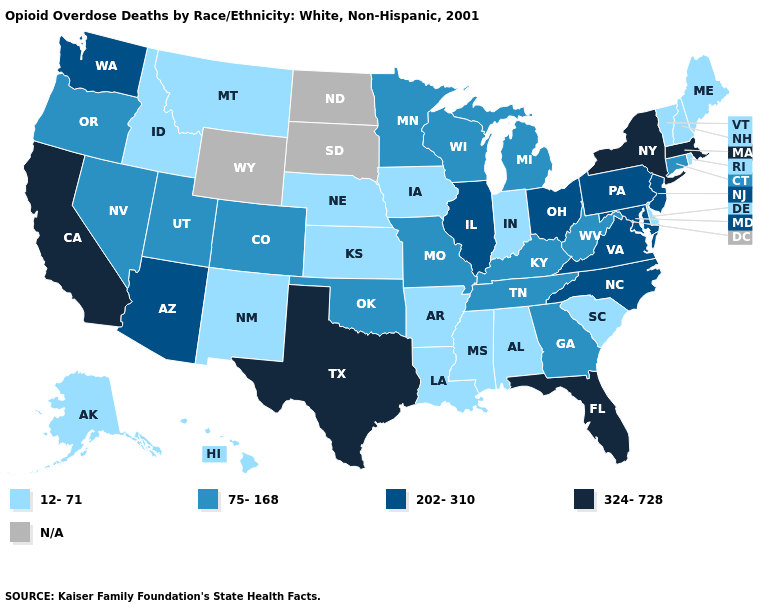What is the highest value in states that border Wisconsin?
Give a very brief answer. 202-310. Which states have the highest value in the USA?
Short answer required. California, Florida, Massachusetts, New York, Texas. Among the states that border Nevada , which have the lowest value?
Keep it brief. Idaho. Which states have the highest value in the USA?
Concise answer only. California, Florida, Massachusetts, New York, Texas. Among the states that border New Hampshire , does Maine have the highest value?
Keep it brief. No. Is the legend a continuous bar?
Write a very short answer. No. Name the states that have a value in the range N/A?
Concise answer only. North Dakota, South Dakota, Wyoming. What is the lowest value in the USA?
Write a very short answer. 12-71. What is the highest value in the West ?
Give a very brief answer. 324-728. What is the value of Rhode Island?
Keep it brief. 12-71. Does Texas have the highest value in the South?
Answer briefly. Yes. Does California have the lowest value in the USA?
Answer briefly. No. Name the states that have a value in the range 324-728?
Short answer required. California, Florida, Massachusetts, New York, Texas. 